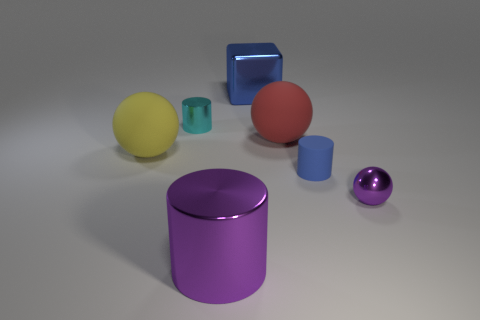Are the objects positioned in any pattern or arrangement? The objects are arranged without a specific pattern, scattered across the space in a way that suggests a random placement. 